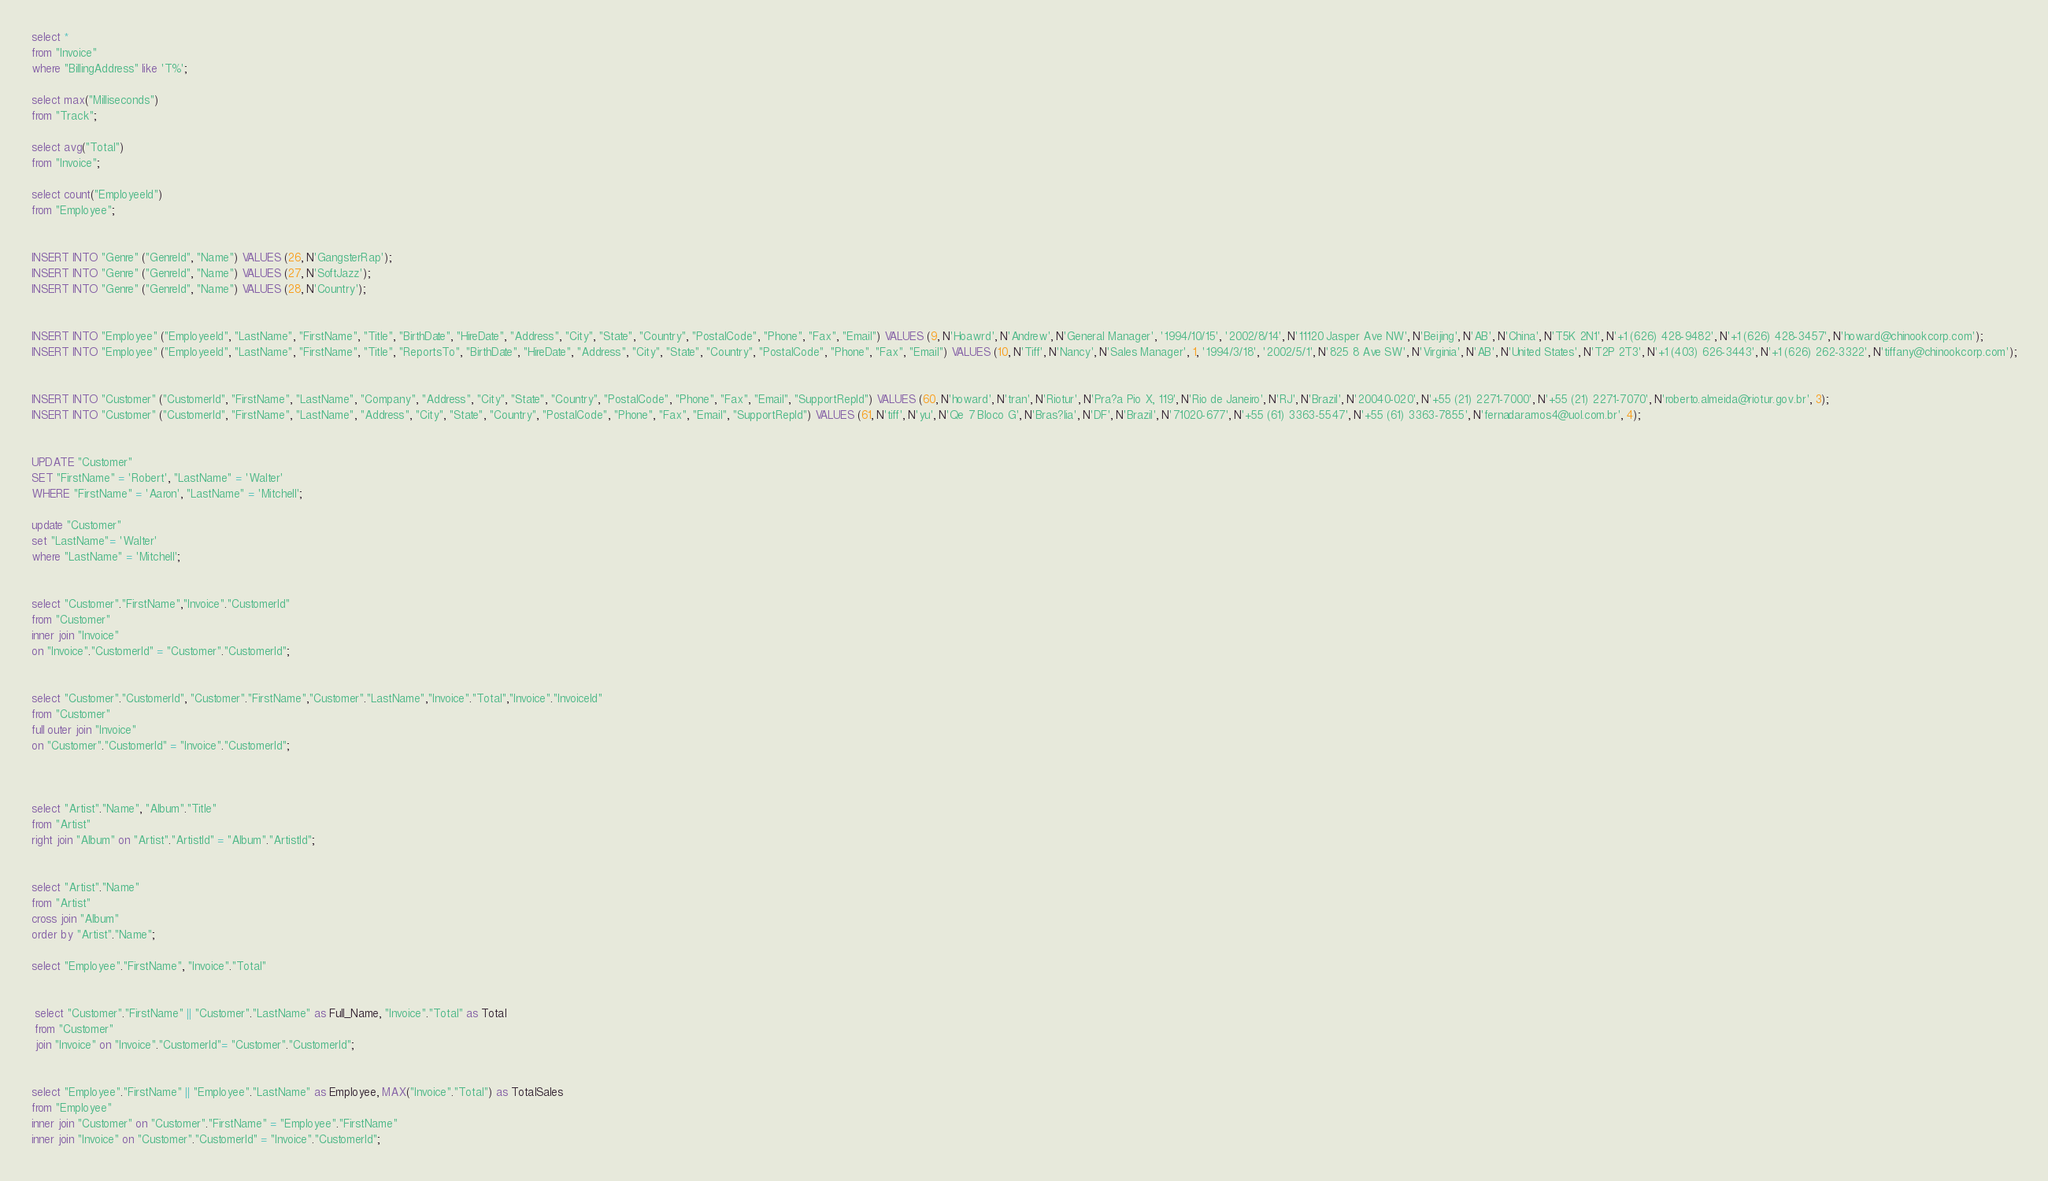<code> <loc_0><loc_0><loc_500><loc_500><_SQL_>
select *
from "Invoice" 
where "BillingAddress" like 'T%';

select max("Milliseconds")
from "Track";

select avg("Total")
from "Invoice";

select count("EmployeeId")
from "Employee";


INSERT INTO "Genre" ("GenreId", "Name") VALUES (26, N'GangsterRap');
INSERT INTO "Genre" ("GenreId", "Name") VALUES (27, N'SoftJazz');
INSERT INTO "Genre" ("GenreId", "Name") VALUES (28, N'Country');


INSERT INTO "Employee" ("EmployeeId", "LastName", "FirstName", "Title", "BirthDate", "HireDate", "Address", "City", "State", "Country", "PostalCode", "Phone", "Fax", "Email") VALUES (9, N'Hoawrd', N'Andrew', N'General Manager', '1994/10/15', '2002/8/14', N'11120 Jasper Ave NW', N'Beijing', N'AB', N'China', N'T5K 2N1', N'+1 (626) 428-9482', N'+1 (626) 428-3457', N'howard@chinookcorp.com');
INSERT INTO "Employee" ("EmployeeId", "LastName", "FirstName", "Title", "ReportsTo", "BirthDate", "HireDate", "Address", "City", "State", "Country", "PostalCode", "Phone", "Fax", "Email") VALUES (10, N'Tiff', N'Nancy', N'Sales Manager', 1, '1994/3/18', '2002/5/1', N'825 8 Ave SW', N'Virginia', N'AB', N'United States', N'T2P 2T3', N'+1 (403) 626-3443', N'+1 (626) 262-3322', N'tiffany@chinookcorp.com');


INSERT INTO "Customer" ("CustomerId", "FirstName", "LastName", "Company", "Address", "City", "State", "Country", "PostalCode", "Phone", "Fax", "Email", "SupportRepId") VALUES (60, N'howard', N'tran', N'Riotur', N'Pra?a Pio X, 119', N'Rio de Janeiro', N'RJ', N'Brazil', N'20040-020', N'+55 (21) 2271-7000', N'+55 (21) 2271-7070', N'roberto.almeida@riotur.gov.br', 3);
INSERT INTO "Customer" ("CustomerId", "FirstName", "LastName", "Address", "City", "State", "Country", "PostalCode", "Phone", "Fax", "Email", "SupportRepId") VALUES (61, N'tiff', N'yu', N'Qe 7 Bloco G', N'Bras?lia', N'DF', N'Brazil', N'71020-677', N'+55 (61) 3363-5547', N'+55 (61) 3363-7855', N'fernadaramos4@uol.com.br', 4);


UPDATE "Customer"
SET "FirstName" = 'Robert', "LastName" = 'Walter'
WHERE "FirstName" = 'Aaron', "LastName" = 'Mitchell';

update "Customer"
set "LastName"= 'Walter'
where "LastName" = 'Mitchell';


select "Customer"."FirstName","Invoice"."CustomerId"
from "Customer"
inner join "Invoice"
on "Invoice"."CustomerId" = "Customer"."CustomerId";


select "Customer"."CustomerId", "Customer"."FirstName","Customer"."LastName","Invoice"."Total","Invoice"."InvoiceId"
from "Customer"
full outer join "Invoice"
on "Customer"."CustomerId" = "Invoice"."CustomerId";



select "Artist"."Name", "Album"."Title"
from "Artist"
right join "Album" on "Artist"."ArtistId" = "Album"."ArtistId";


select "Artist"."Name"
from "Artist"
cross join "Album"
order by "Artist"."Name";

select "Employee"."FirstName", "Invoice"."Total"
  

 select "Customer"."FirstName" || "Customer"."LastName" as Full_Name, "Invoice"."Total" as Total
 from "Customer"
 join "Invoice" on "Invoice"."CustomerId"= "Customer"."CustomerId";
 

select "Employee"."FirstName" || "Employee"."LastName" as Employee, MAX("Invoice"."Total") as TotalSales
from "Employee"
inner join "Customer" on "Customer"."FirstName" = "Employee"."FirstName"
inner join "Invoice" on "Customer"."CustomerId" = "Invoice"."CustomerId";
</code> 